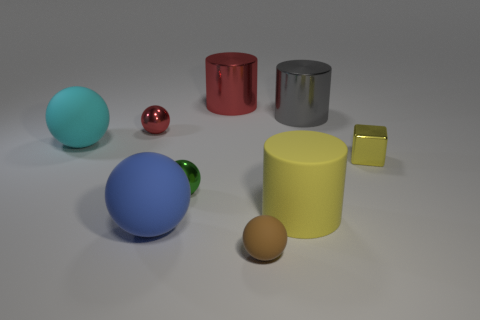Subtract 2 balls. How many balls are left? 3 Subtract all red balls. How many balls are left? 4 Subtract all red shiny balls. How many balls are left? 4 Subtract all purple balls. Subtract all blue cylinders. How many balls are left? 5 Subtract all balls. How many objects are left? 4 Add 9 big shiny spheres. How many big shiny spheres exist? 9 Subtract 0 gray balls. How many objects are left? 9 Subtract all yellow cylinders. Subtract all yellow things. How many objects are left? 6 Add 5 brown objects. How many brown objects are left? 6 